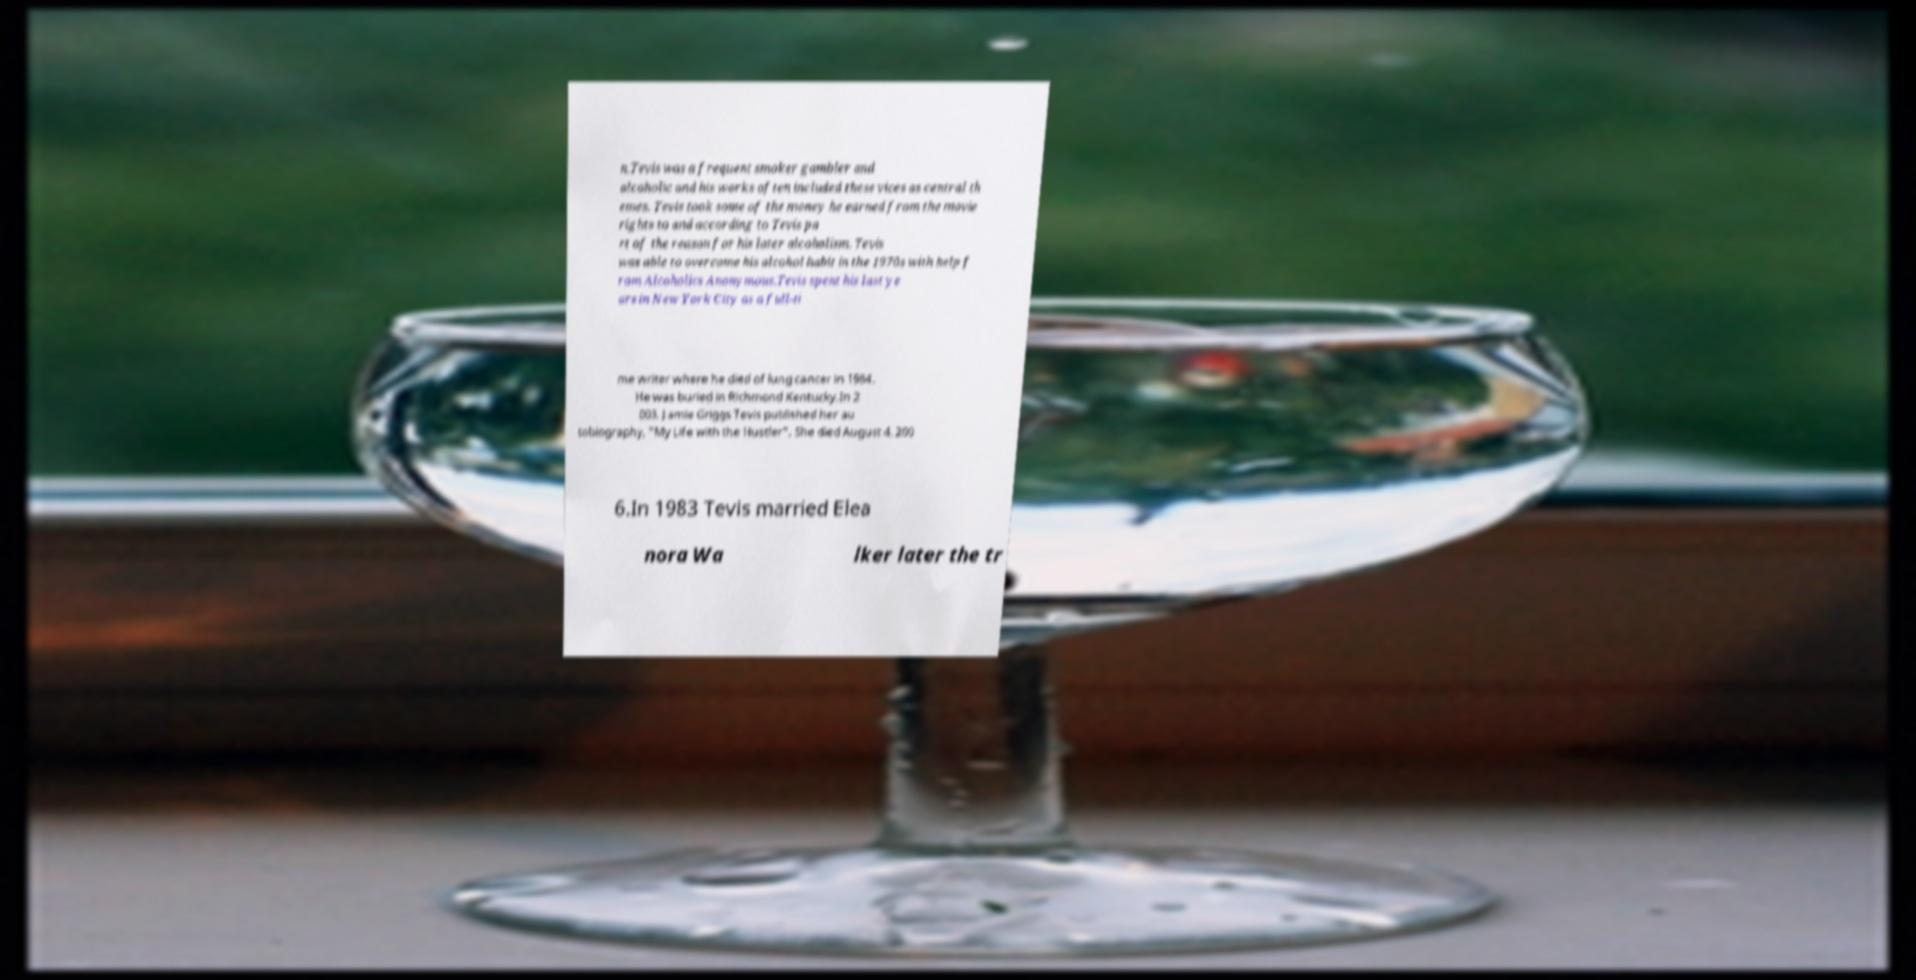There's text embedded in this image that I need extracted. Can you transcribe it verbatim? n.Tevis was a frequent smoker gambler and alcoholic and his works often included these vices as central th emes. Tevis took some of the money he earned from the movie rights to and according to Tevis pa rt of the reason for his later alcoholism. Tevis was able to overcome his alcohol habit in the 1970s with help f rom Alcoholics Anonymous.Tevis spent his last ye ars in New York City as a full-ti me writer where he died of lung cancer in 1984. He was buried in Richmond Kentucky.In 2 003, Jamie Griggs Tevis published her au tobiography, "My Life with the Hustler". She died August 4, 200 6.In 1983 Tevis married Elea nora Wa lker later the tr 